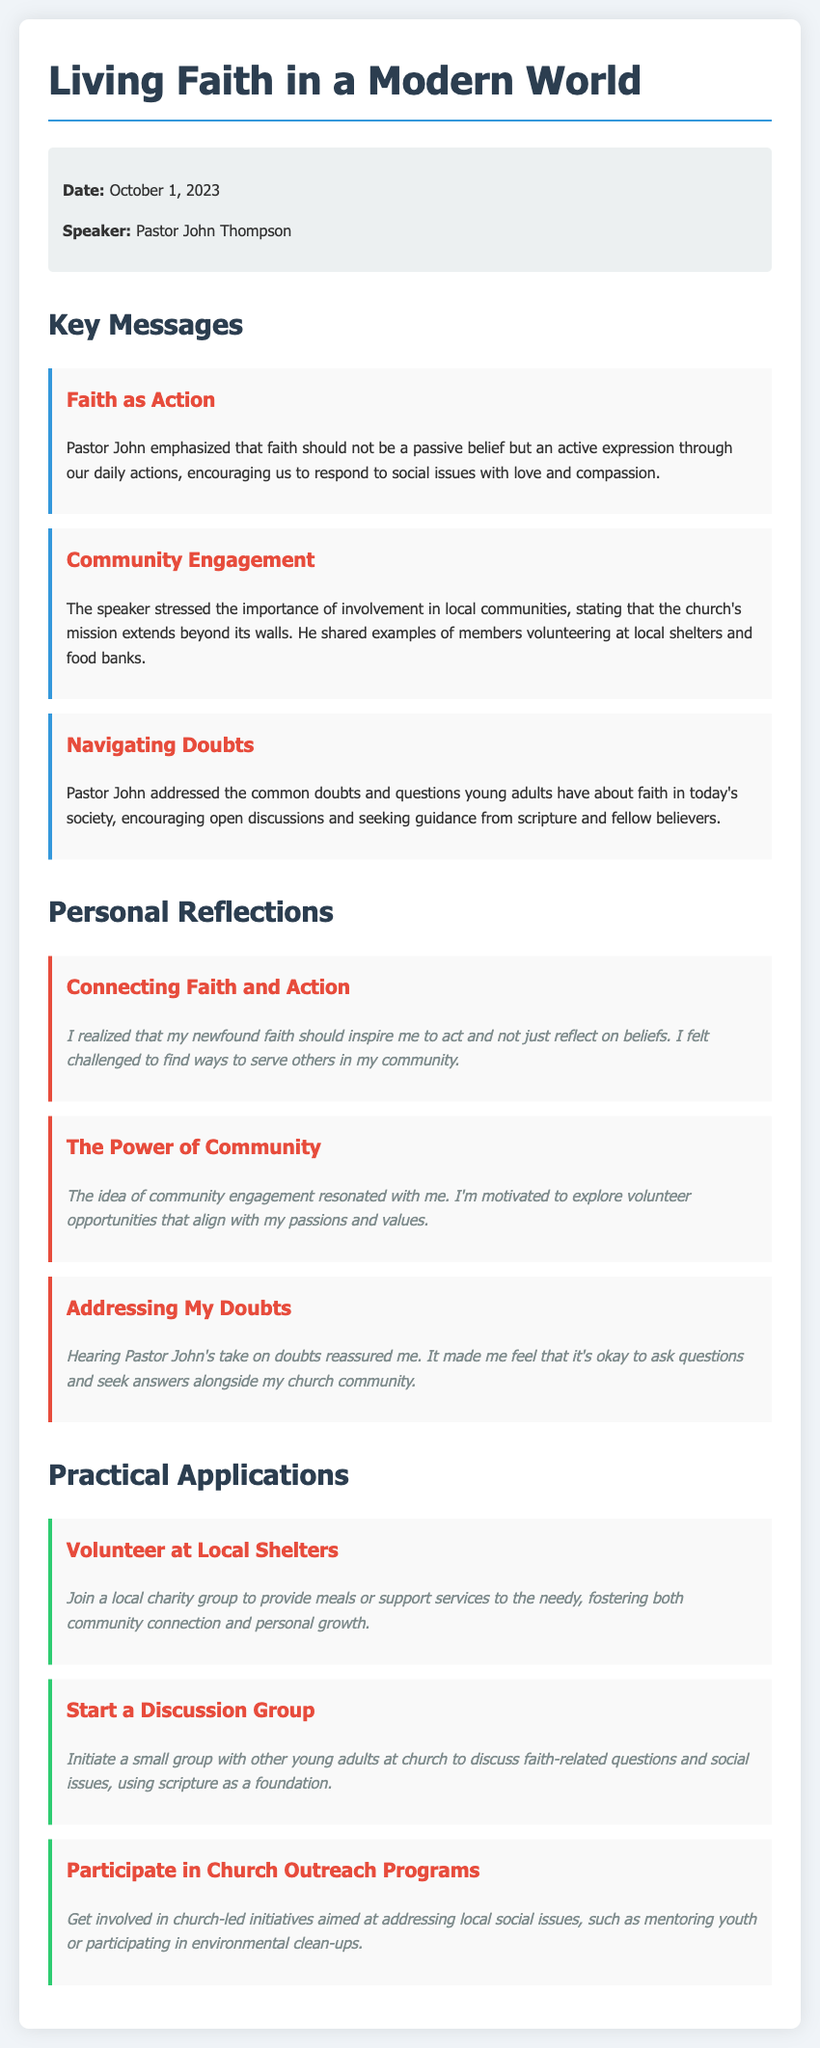What is the date of the sermon? The date of the sermon is mentioned in the document under the sermon info section.
Answer: October 1, 2023 Who was the speaker at the sermon? The speaker's name is provided in the same sermon info section.
Answer: Pastor John Thompson What is one key message related to community engagement? This key message emphasizes the church's mission extends beyond its walls.
Answer: Involvement in local communities What is a personal reflection on connecting faith and action? This reflection is a personal thought that connects to the sermon message about faith as action.
Answer: My newfound faith should inspire me to act What is one practical application suggested in the document? The document lists several practical applications, one of which is specified here.
Answer: Volunteer at Local Shelters How many key messages are presented in total? The total number of key messages can be counted from the key messages section of the document.
Answer: Three What is the theme of the sermon? The overall focus or theme is conveyed in the title of the document.
Answer: Living Faith in a Modern World What does Pastor John encourage regarding doubts? The document highlights specific advice from Pastor John on addressing doubts.
Answer: Open discussions What activity can young adults initiate according to the practical applications? This document outlines specific activities that young adults can start based on the sermon.
Answer: Start a Discussion Group 